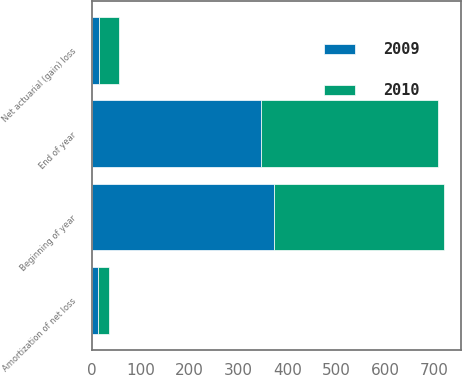<chart> <loc_0><loc_0><loc_500><loc_500><stacked_bar_chart><ecel><fcel>Beginning of year<fcel>Net actuarial (gain) loss<fcel>Amortization of net loss<fcel>End of year<nl><fcel>2010<fcel>346<fcel>41<fcel>23<fcel>363<nl><fcel>2009<fcel>374<fcel>15<fcel>13<fcel>346<nl></chart> 